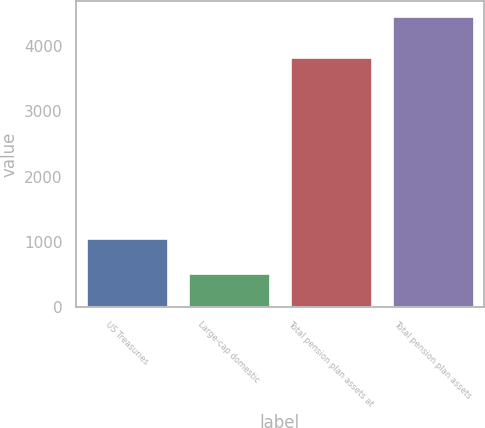Convert chart to OTSL. <chart><loc_0><loc_0><loc_500><loc_500><bar_chart><fcel>US Treasuries<fcel>Large-cap domestic<fcel>Total pension plan assets at<fcel>Total pension plan assets<nl><fcel>1048<fcel>512<fcel>3830<fcel>4470<nl></chart> 